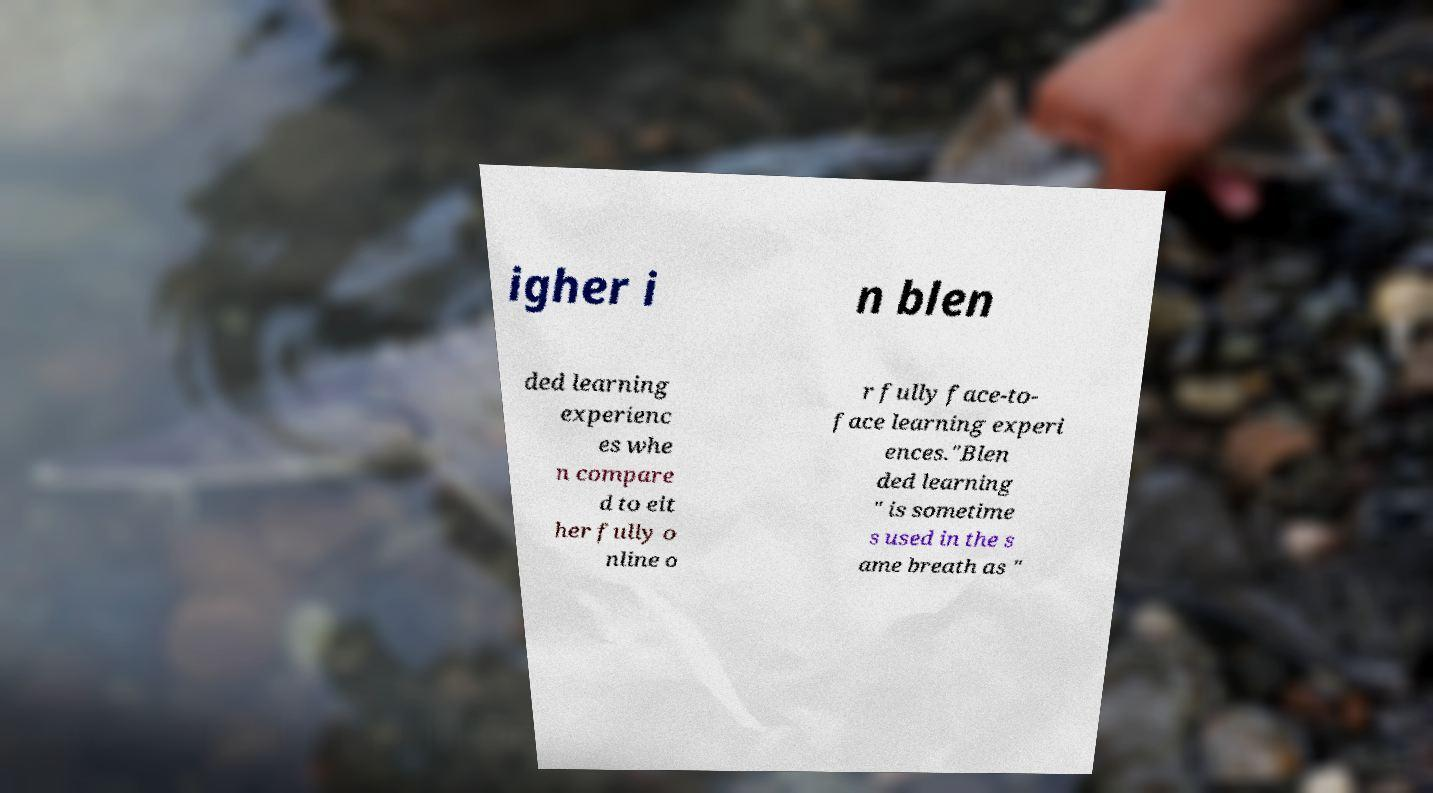What messages or text are displayed in this image? I need them in a readable, typed format. igher i n blen ded learning experienc es whe n compare d to eit her fully o nline o r fully face-to- face learning experi ences."Blen ded learning " is sometime s used in the s ame breath as " 